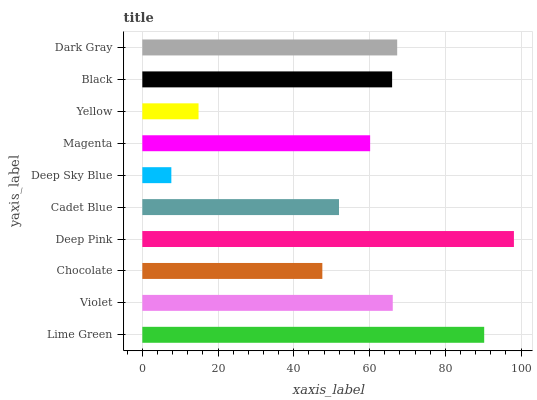Is Deep Sky Blue the minimum?
Answer yes or no. Yes. Is Deep Pink the maximum?
Answer yes or no. Yes. Is Violet the minimum?
Answer yes or no. No. Is Violet the maximum?
Answer yes or no. No. Is Lime Green greater than Violet?
Answer yes or no. Yes. Is Violet less than Lime Green?
Answer yes or no. Yes. Is Violet greater than Lime Green?
Answer yes or no. No. Is Lime Green less than Violet?
Answer yes or no. No. Is Black the high median?
Answer yes or no. Yes. Is Magenta the low median?
Answer yes or no. Yes. Is Violet the high median?
Answer yes or no. No. Is Violet the low median?
Answer yes or no. No. 